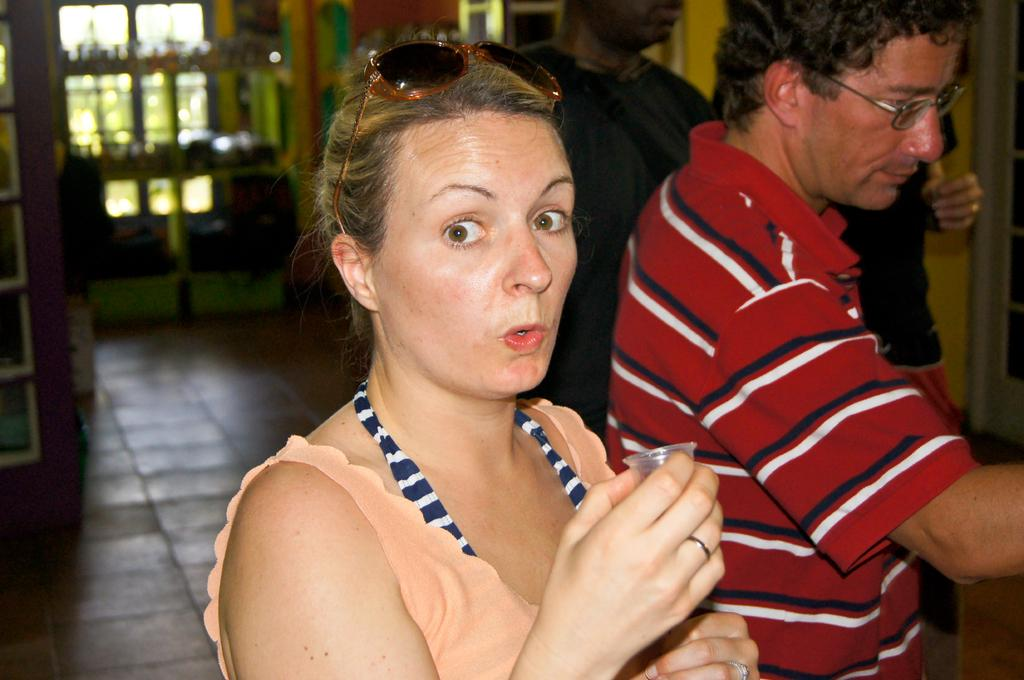What is the main subject of the image? The main subject of the image is a group of people. Can you describe the man on the right side of the image? The man on the right side of the image is wearing spectacles. How would you describe the background of the image? The background of the image appears blurry. What type of wilderness can be seen in the background of the image? There is no wilderness present in the image; the background appears blurry but does not show any specific environment. 